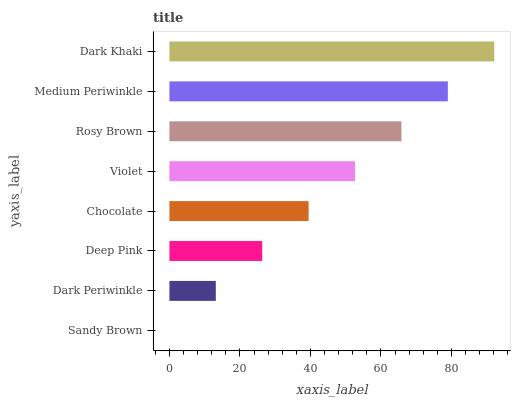Is Sandy Brown the minimum?
Answer yes or no. Yes. Is Dark Khaki the maximum?
Answer yes or no. Yes. Is Dark Periwinkle the minimum?
Answer yes or no. No. Is Dark Periwinkle the maximum?
Answer yes or no. No. Is Dark Periwinkle greater than Sandy Brown?
Answer yes or no. Yes. Is Sandy Brown less than Dark Periwinkle?
Answer yes or no. Yes. Is Sandy Brown greater than Dark Periwinkle?
Answer yes or no. No. Is Dark Periwinkle less than Sandy Brown?
Answer yes or no. No. Is Violet the high median?
Answer yes or no. Yes. Is Chocolate the low median?
Answer yes or no. Yes. Is Dark Khaki the high median?
Answer yes or no. No. Is Deep Pink the low median?
Answer yes or no. No. 